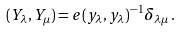<formula> <loc_0><loc_0><loc_500><loc_500>( Y _ { \lambda } , Y _ { \mu } ) = e ( y _ { \lambda } , y _ { \lambda } ) ^ { - 1 } \delta _ { \lambda \mu } \, .</formula> 